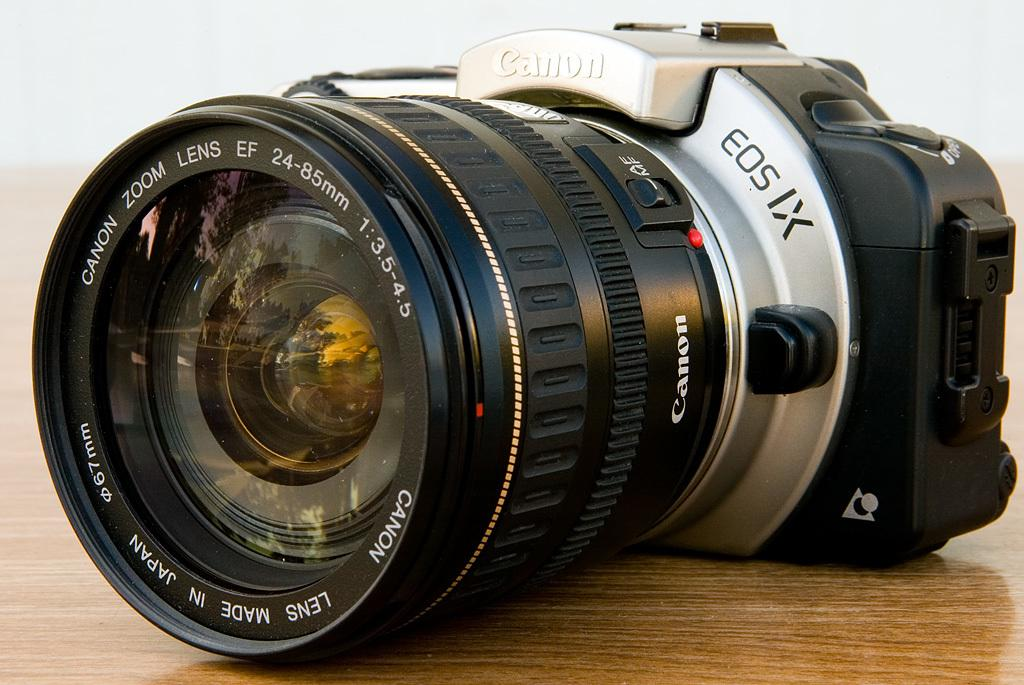What object is the main focus of the image? There is a camera in the image. What type of surface is the camera placed on? The camera is on a wooden floor. Where is the camera positioned in the image? The camera is in the middle of the image. What type of shoes is the camera wearing in the image? The camera is an inanimate object and does not wear shoes. Is there a mask covering the camera lens in the image? There is no mention of a mask in the provided facts, and therefore it cannot be determined if one is present. 